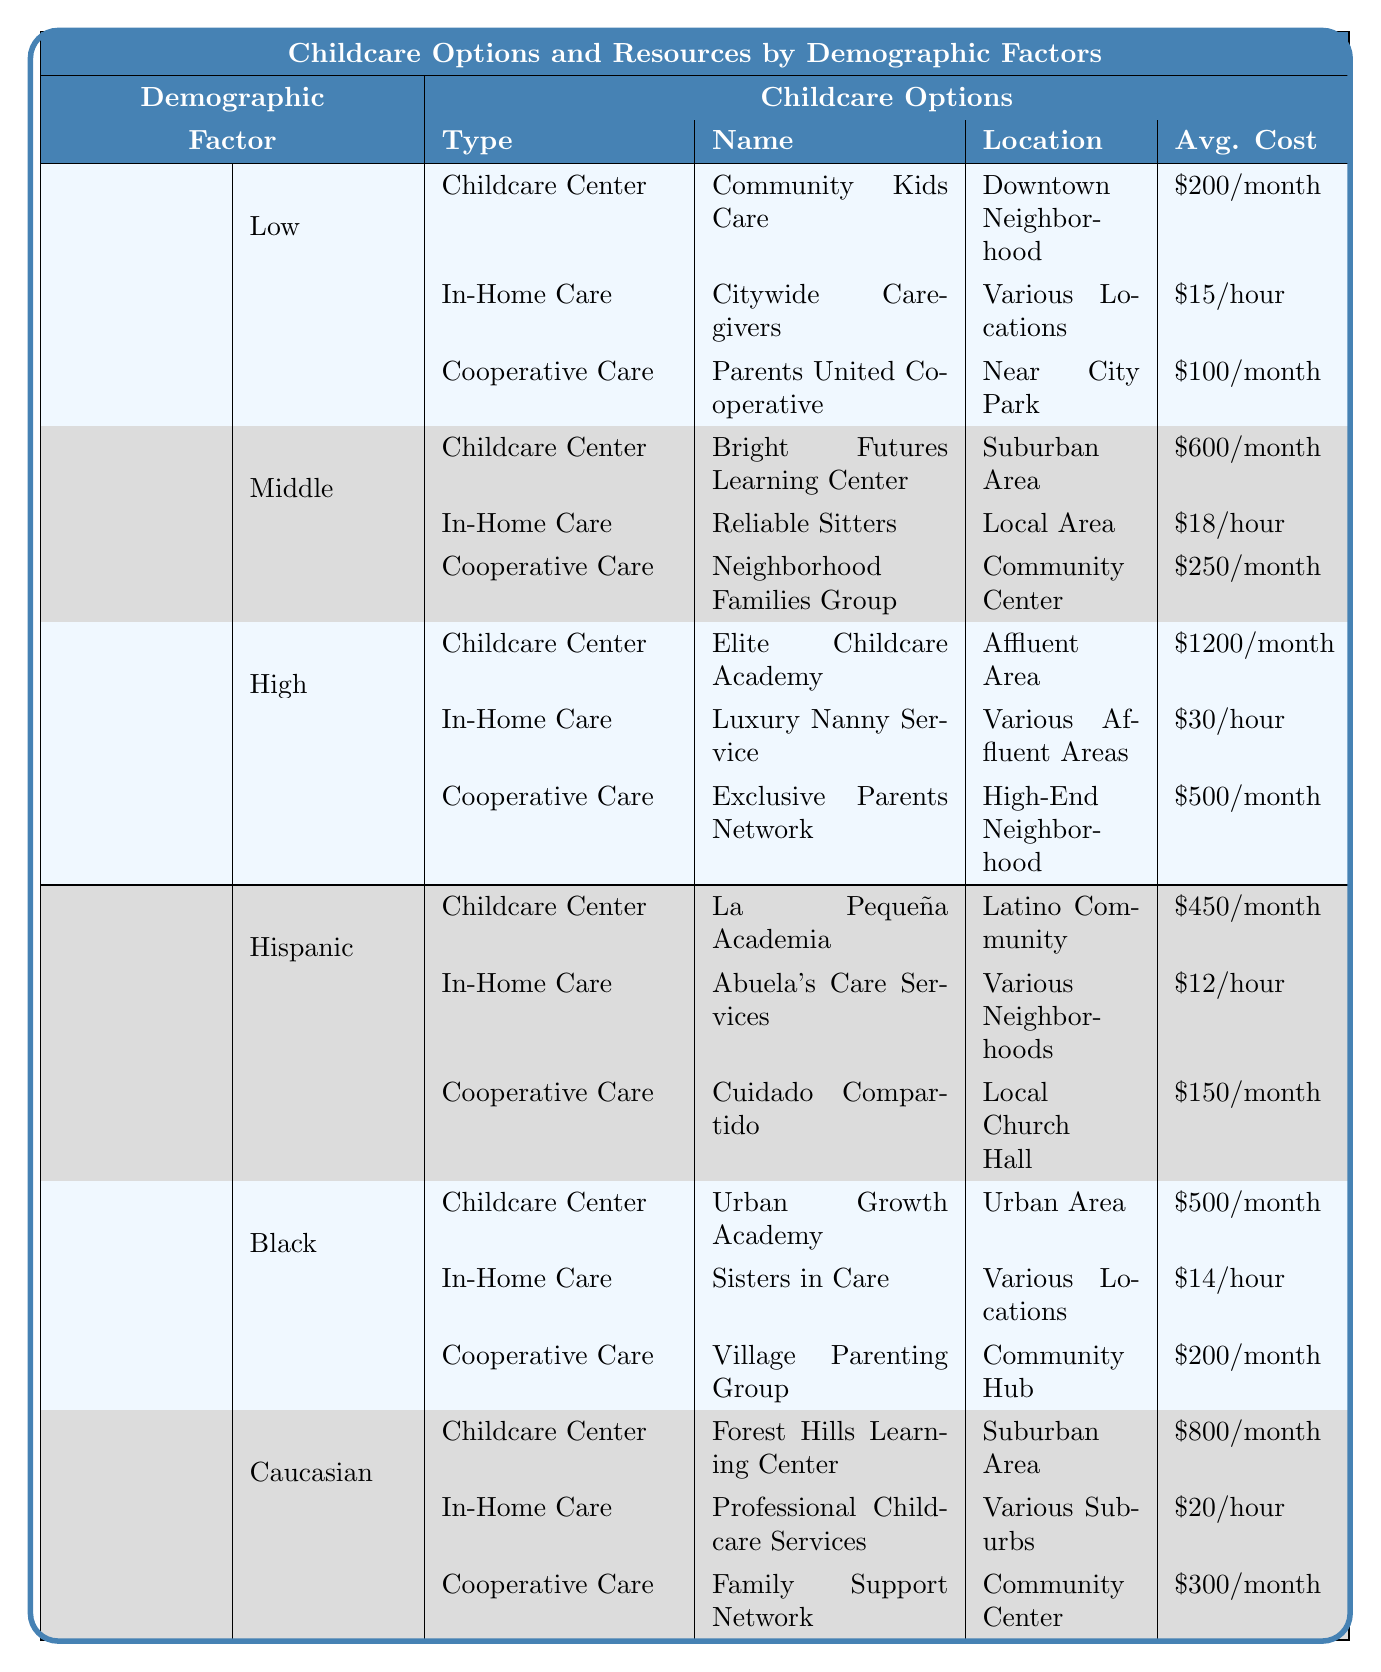What is the average cost per month for childcare centers catering to low-income families? The table lists one childcare center for low-income families, "Community Kids Care," which has an average cost of $200 per month. Therefore, the average cost is simply $200.
Answer: $200 Which childcare option has the highest average cost per month? The table shows that the "Elite Childcare Academy" has the highest average cost per month at $1200. No other option exceeds this amount, making it the highest.
Answer: $1200 Is there financial aid available for families using "Abuela's Care Services"? According to the table, "Abuela's Care Services" provides reduced fees for community families. Therefore, the answer is yes, financial aid is available.
Answer: Yes How much more does the highest average cost for in-home care compare to the lowest? The table states that the highest in-home care cost is "$30/hour" for "Luxury Nanny Service," while the lowest is "$15/hour" for "Citywide Caregivers." Calculating the difference gives $30 - $15 = $15.
Answer: $15 What is the total average cost per month for cooperative care options across all income levels? The cooperative care monthly costs are $100 (low) + $250 (middle) + $500 (high) = $850. The total average cost per month for cooperative care options is therefore $850.
Answer: $850 For Black families, which childcare option is the least expensive? The least expensive option for Black families is "Sisters in Care," which costs $14/hour for in-home care. Comparing it to other options shows it's the least expensive.
Answer: $14/hour Do all childcare centers have financial aid options? Reviewing the table indicates that not all childcare centers have financial aid. For example, "Elite Childcare Academy" explicitly states that it has no financial aid. Therefore, the answer is no.
Answer: No What percentage of the cooperative care options for Hispanic families is subsidized by community donations? The cooperative care option for Hispanic families, "Cuidado Compartido," is supported by community donations, indicating it is subsidized. Therefore, it is 100% subsidized by community donations for that specific option.
Answer: 100% Which demographic has the highest average monthly cost for childcare centers? Upon examining the table, the average monthly costs for childcare centers are: Low = $200, Middle = $600, High = $1200. Here, the High income level has the highest average.
Answer: High income level Using the average cost of childcare centers for Middle-income families, what would it cost for three months of care? The average monthly cost for a childcare center for Middle-income families is $600. Therefore, for three months, it would be $600 * 3 = $1800.
Answer: $1800 